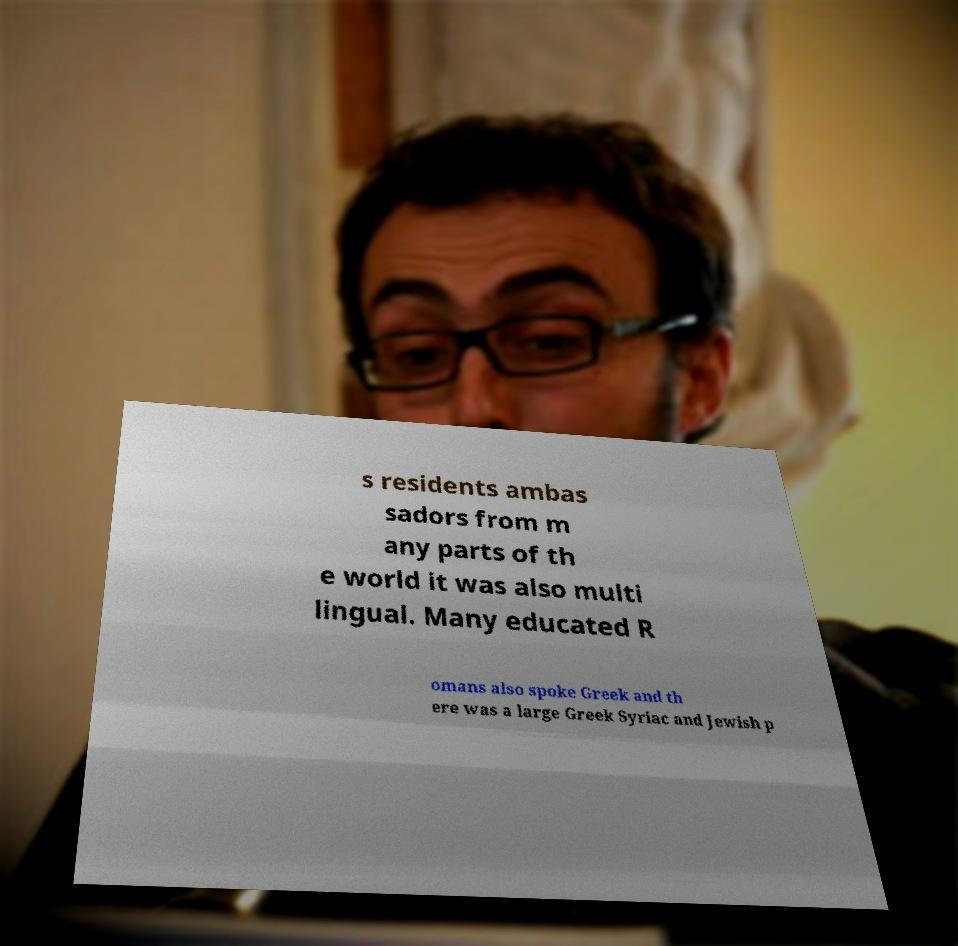I need the written content from this picture converted into text. Can you do that? s residents ambas sadors from m any parts of th e world it was also multi lingual. Many educated R omans also spoke Greek and th ere was a large Greek Syriac and Jewish p 